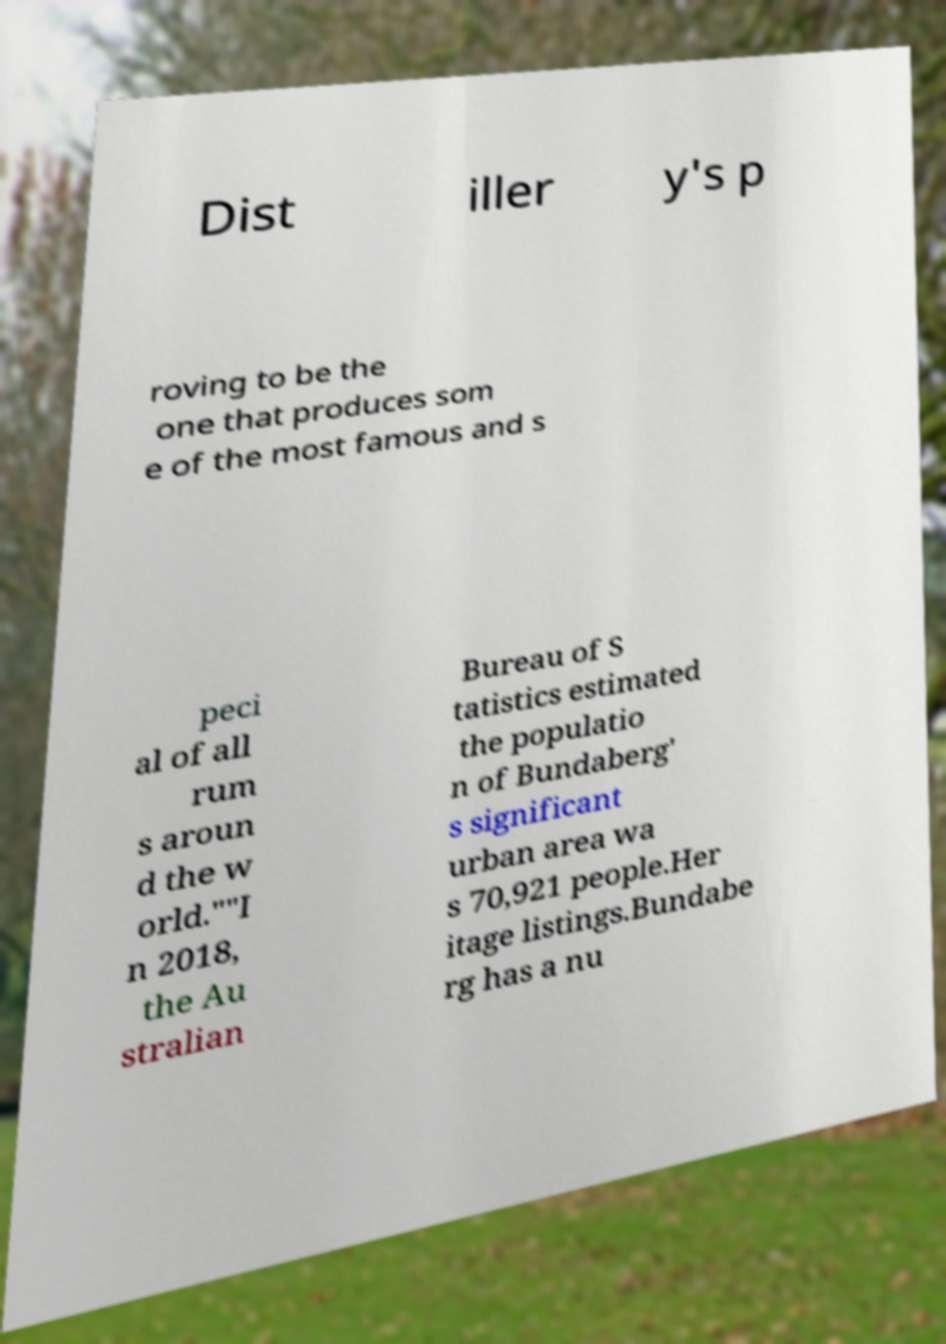For documentation purposes, I need the text within this image transcribed. Could you provide that? Dist iller y's p roving to be the one that produces som e of the most famous and s peci al of all rum s aroun d the w orld.""I n 2018, the Au stralian Bureau of S tatistics estimated the populatio n of Bundaberg' s significant urban area wa s 70,921 people.Her itage listings.Bundabe rg has a nu 